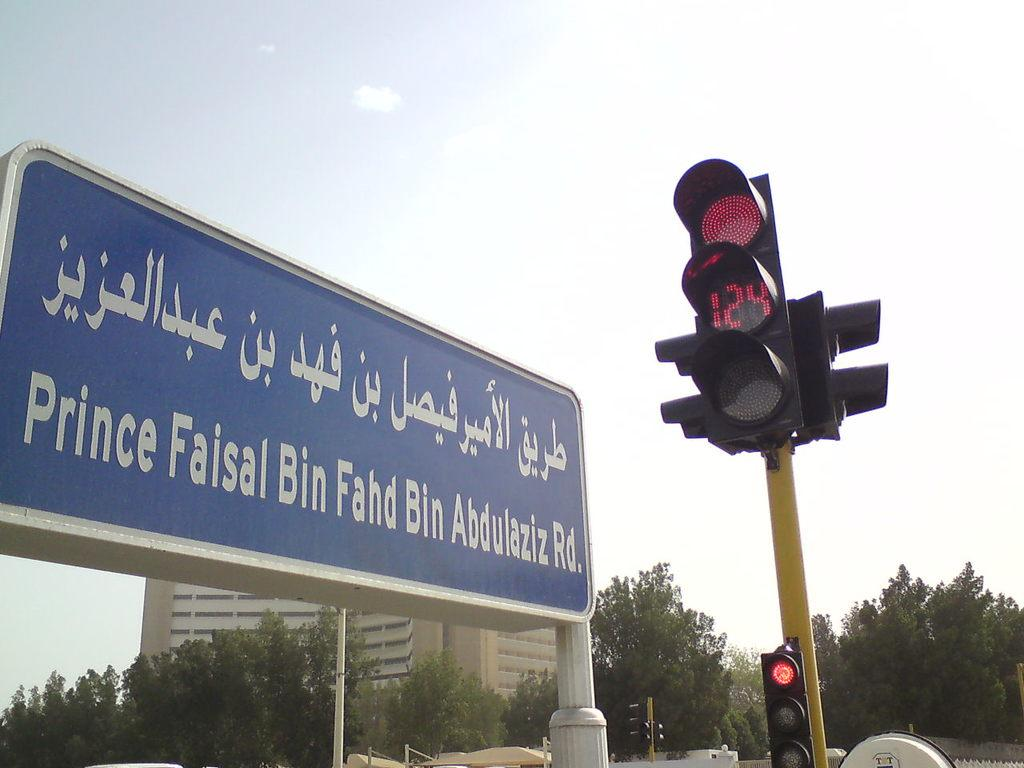What is the main object in the image? There is a board in the image. What other structures or objects can be seen in the image? There is a traffic pole, a fence, trees, buildings, and the sky is visible in the image. Can you describe the setting of the image? The image appears to be taken in an urban or suburban area, with buildings, trees, and a traffic pole present. What time of day might the image have been taken? The image was likely taken during the day, as the sky is visible and there is no indication of darkness. What type of insurance policy is advertised on the board in the image? There is no insurance policy advertised on the board in the image; it is simply a board with no visible text or images related to insurance. 